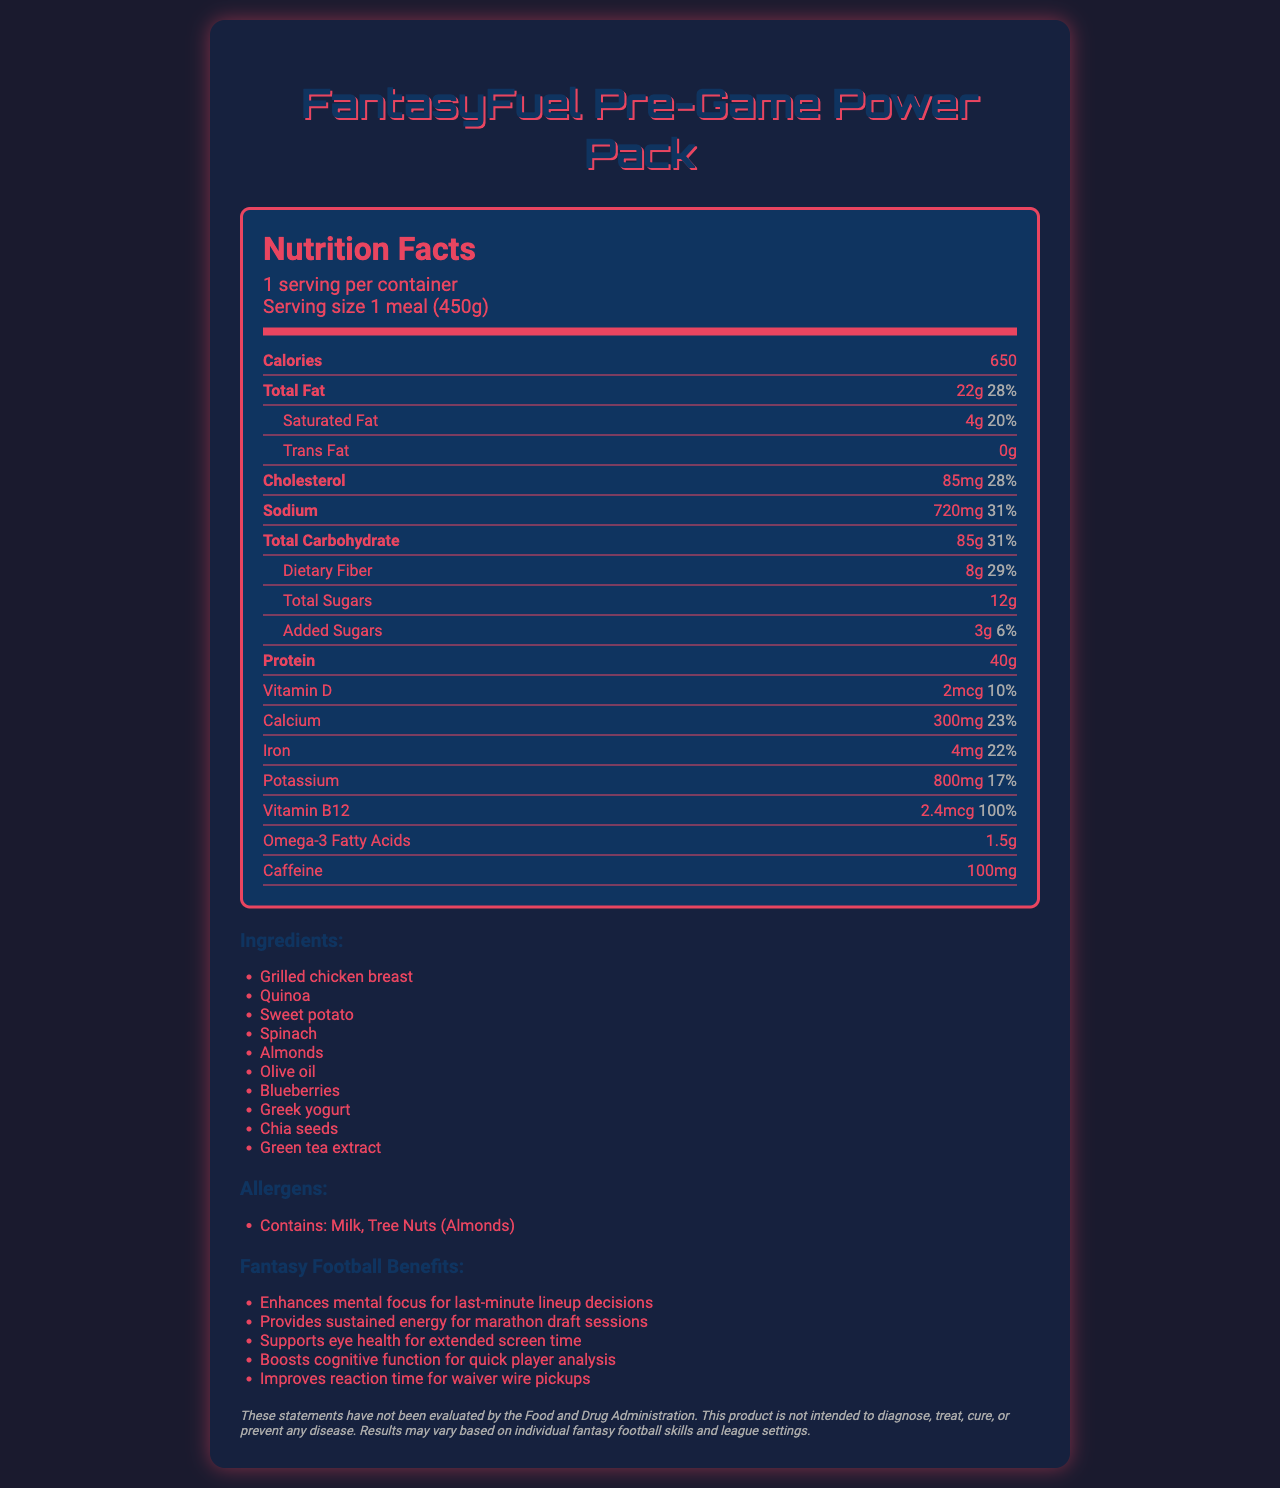what is the serving size of the FantasyFuel Pre-Game Power Pack? The serving size is explicitly stated as "1 meal (450g)" in the nutrition facts.
Answer: 1 meal (450g) how many calories are in one serving of the FantasyFuel Pre-Game Power Pack? The nutrition label lists the number of calories as 650.
Answer: 650 what is the amount of protein per serving? The document states that each serving contains 40g of protein.
Answer: 40g how much saturated fat does the pre-game meal contain? According to the nutrition facts, there are 4g of saturated fat per serving.
Answer: 4g how much dietary fiber is in the meal? The label shows that the meal contains 8g of dietary fiber.
Answer: 8g what are the allergens present in the FantasyFuel Pre-Game Power Pack? The allergens section lists Milk and Tree Nuts (Almonds).
Answer: Milk, Tree Nuts (Almonds) which vitamin has the highest daily value percentage in the meal? A. Vitamin D B. Calcium C. Iron D. Vitamin B12 The daily value percentage of Vitamin B12 is 100%, which is the highest among the listed vitamins and minerals.
Answer: D. Vitamin B12 how much sodium does one serving of the FantasyFuel Pre-Game Power Pack contain? A. 600mg B. 720mg C. 500mg D. 850mg The nutrition facts show that the meal contains 720mg of sodium.
Answer: B. 720mg is there any trans fat in the FantasyFuel Pre-Game Power Pack? The document states that the amount of trans fat is 0g.
Answer: No what is one of the benefits of the FantasyFuel Pre-Game Power Pack for fantasy football players? This is one of the listed fantasy football benefits.
Answer: Enhances mental focus for last-minute lineup decisions how much caffeine is included in each serving? The nutrition label indicates that each serving contains 100mg of caffeine.
Answer: 100mg describe the main idea of the document. The summary highlights the primary purpose of the document, which is to offer a comprehensive overview of the nutritional content and benefits of the FantasyFuel Pre-Game Power Pack.
Answer: The document provides detailed nutrition facts for the FantasyFuel Pre-Game Power Pack, a meal designed specifically for fantasy football players. It includes information on serving size, calorie content, various nutrients, ingredients, allergens, and specific benefits aimed at enhancing fantasy football performance. what is the source of omega-3 fatty acids in the meal? The document does not specify the source of omega-3 fatty acids among the ingredients listed.
Answer: Not enough information 